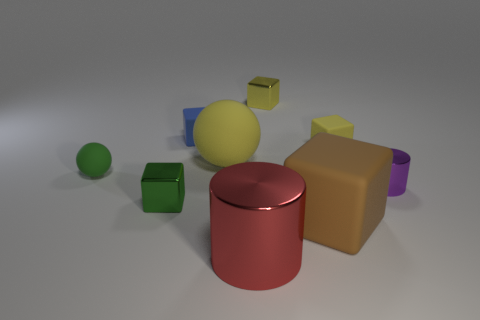Subtract 1 blocks. How many blocks are left? 4 Subtract all blue blocks. How many blocks are left? 4 Subtract all yellow shiny cubes. How many cubes are left? 4 Subtract all cyan cubes. Subtract all green spheres. How many cubes are left? 5 Subtract all cylinders. How many objects are left? 7 Add 5 small yellow cubes. How many small yellow cubes are left? 7 Add 4 small purple shiny cubes. How many small purple shiny cubes exist? 4 Subtract 1 yellow blocks. How many objects are left? 8 Subtract all balls. Subtract all big yellow rubber balls. How many objects are left? 6 